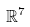<formula> <loc_0><loc_0><loc_500><loc_500>\mathbb { R } ^ { 7 }</formula> 